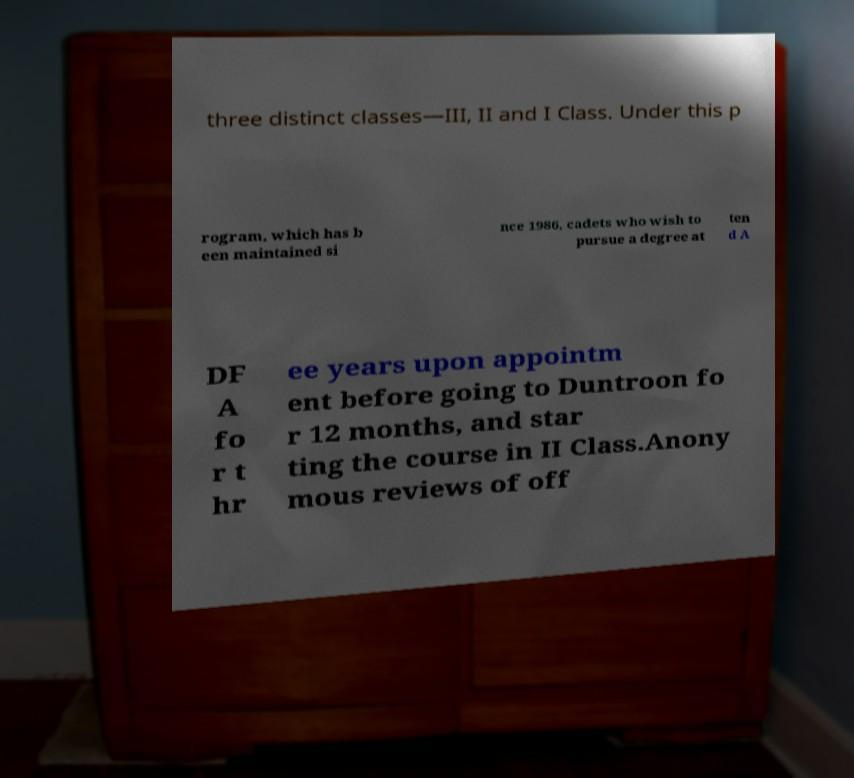What messages or text are displayed in this image? I need them in a readable, typed format. three distinct classes—III, II and I Class. Under this p rogram, which has b een maintained si nce 1986, cadets who wish to pursue a degree at ten d A DF A fo r t hr ee years upon appointm ent before going to Duntroon fo r 12 months, and star ting the course in II Class.Anony mous reviews of off 